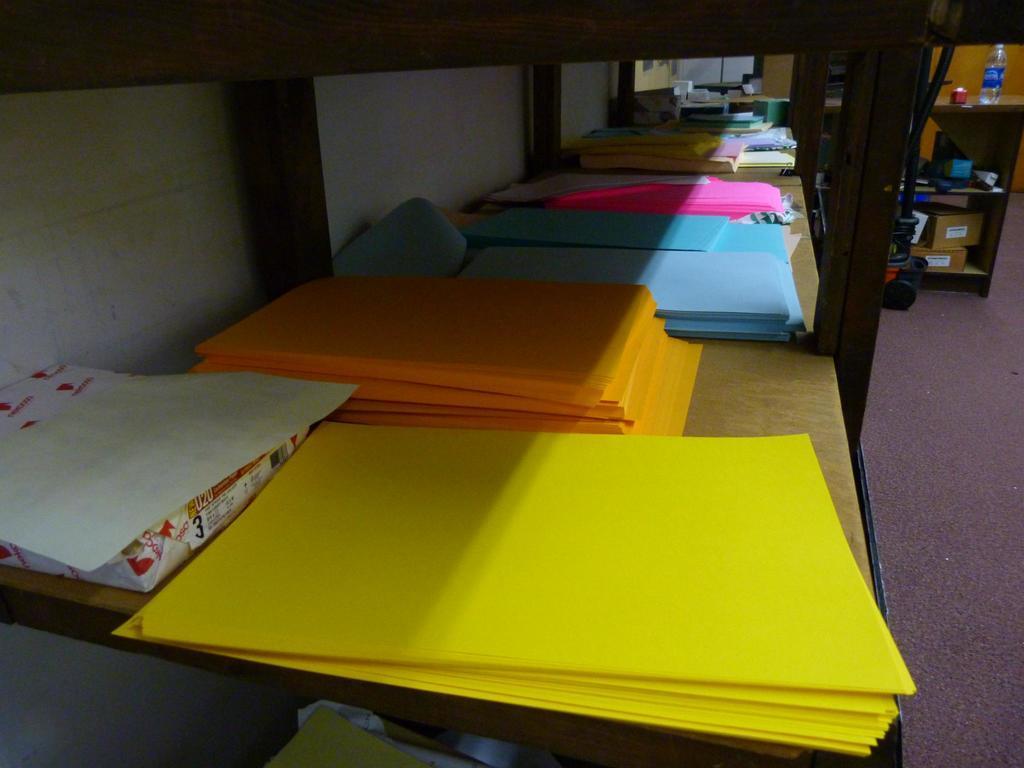Describe this image in one or two sentences. In this picture there are some color papers kept in a shelf 